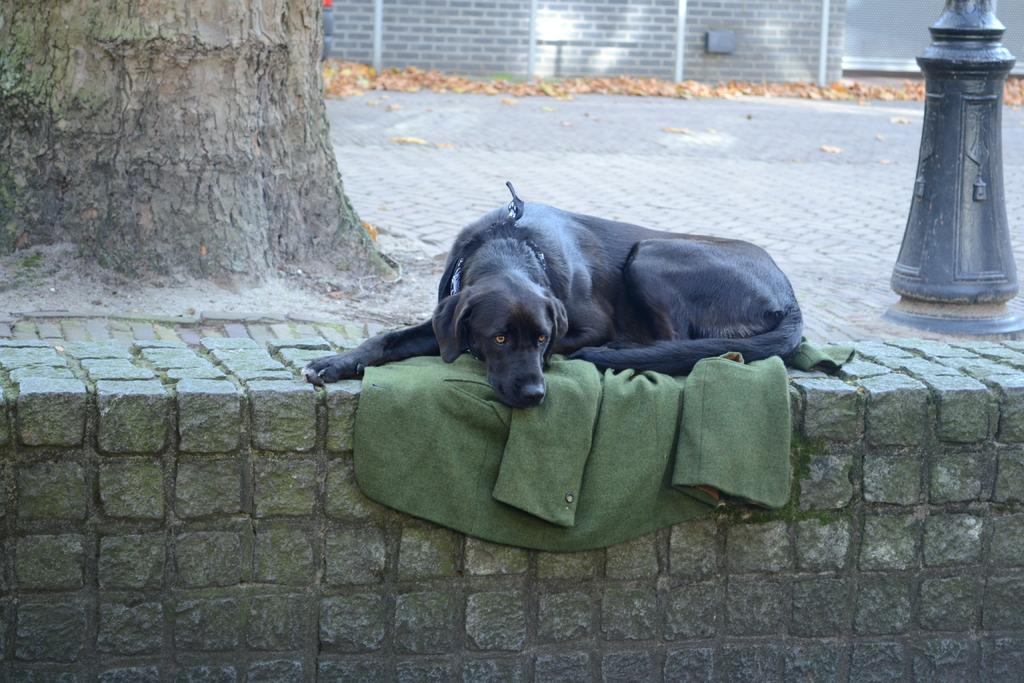What type of animal can be seen in the image? There is a black dog in the image. What is the dog lying on? The dog is lying on a cloth. What structures are visible in the background of the image? There is a wall and a tree in the image. What can be found on the ground in the image? Dried leaves are present on the ground in the image. What type of skin condition does the dog have in the image? There is no indication of a skin condition in the image; the dog appears to have normal fur. 